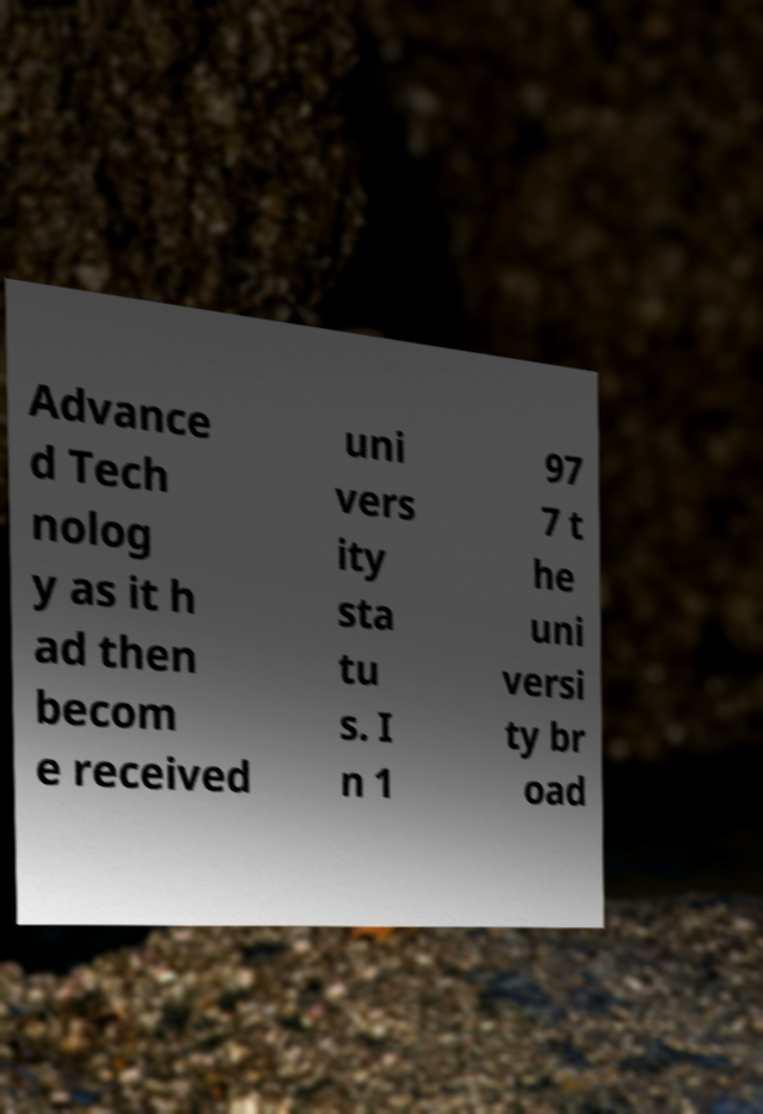Could you extract and type out the text from this image? Advance d Tech nolog y as it h ad then becom e received uni vers ity sta tu s. I n 1 97 7 t he uni versi ty br oad 